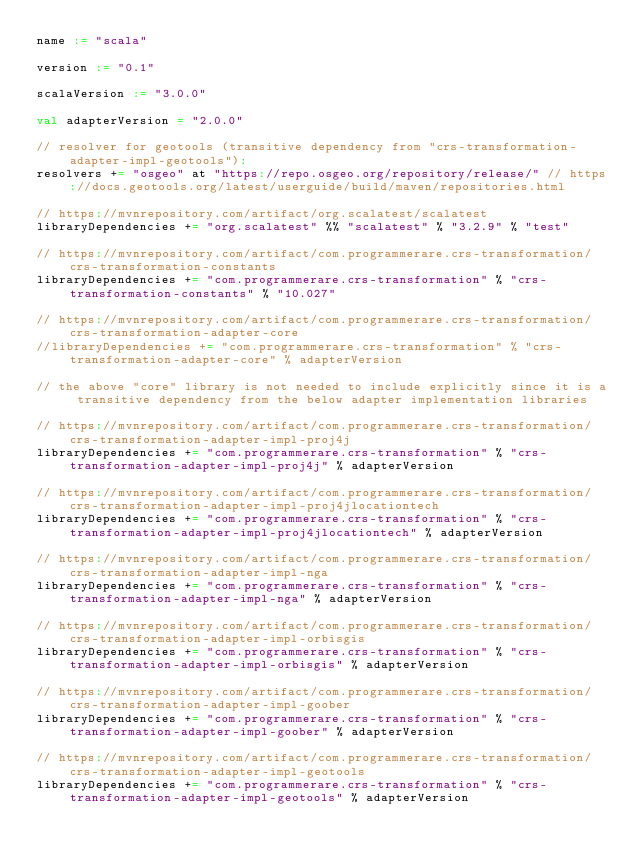Convert code to text. <code><loc_0><loc_0><loc_500><loc_500><_Scala_>name := "scala"

version := "0.1"

scalaVersion := "3.0.0"

val adapterVersion = "2.0.0"

// resolver for geotools (transitive dependency from "crs-transformation-adapter-impl-geotools"): 
resolvers += "osgeo" at "https://repo.osgeo.org/repository/release/" // https://docs.geotools.org/latest/userguide/build/maven/repositories.html

// https://mvnrepository.com/artifact/org.scalatest/scalatest
libraryDependencies += "org.scalatest" %% "scalatest" % "3.2.9" % "test"

// https://mvnrepository.com/artifact/com.programmerare.crs-transformation/crs-transformation-constants
libraryDependencies += "com.programmerare.crs-transformation" % "crs-transformation-constants" % "10.027"

// https://mvnrepository.com/artifact/com.programmerare.crs-transformation/crs-transformation-adapter-core
//libraryDependencies += "com.programmerare.crs-transformation" % "crs-transformation-adapter-core" % adapterVersion

// the above "core" library is not needed to include explicitly since it is a transitive dependency from the below adapter implementation libraries

// https://mvnrepository.com/artifact/com.programmerare.crs-transformation/crs-transformation-adapter-impl-proj4j
libraryDependencies += "com.programmerare.crs-transformation" % "crs-transformation-adapter-impl-proj4j" % adapterVersion

// https://mvnrepository.com/artifact/com.programmerare.crs-transformation/crs-transformation-adapter-impl-proj4jlocationtech
libraryDependencies += "com.programmerare.crs-transformation" % "crs-transformation-adapter-impl-proj4jlocationtech" % adapterVersion

// https://mvnrepository.com/artifact/com.programmerare.crs-transformation/crs-transformation-adapter-impl-nga
libraryDependencies += "com.programmerare.crs-transformation" % "crs-transformation-adapter-impl-nga" % adapterVersion

// https://mvnrepository.com/artifact/com.programmerare.crs-transformation/crs-transformation-adapter-impl-orbisgis
libraryDependencies += "com.programmerare.crs-transformation" % "crs-transformation-adapter-impl-orbisgis" % adapterVersion

// https://mvnrepository.com/artifact/com.programmerare.crs-transformation/crs-transformation-adapter-impl-goober
libraryDependencies += "com.programmerare.crs-transformation" % "crs-transformation-adapter-impl-goober" % adapterVersion

// https://mvnrepository.com/artifact/com.programmerare.crs-transformation/crs-transformation-adapter-impl-geotools
libraryDependencies += "com.programmerare.crs-transformation" % "crs-transformation-adapter-impl-geotools" % adapterVersion

</code> 